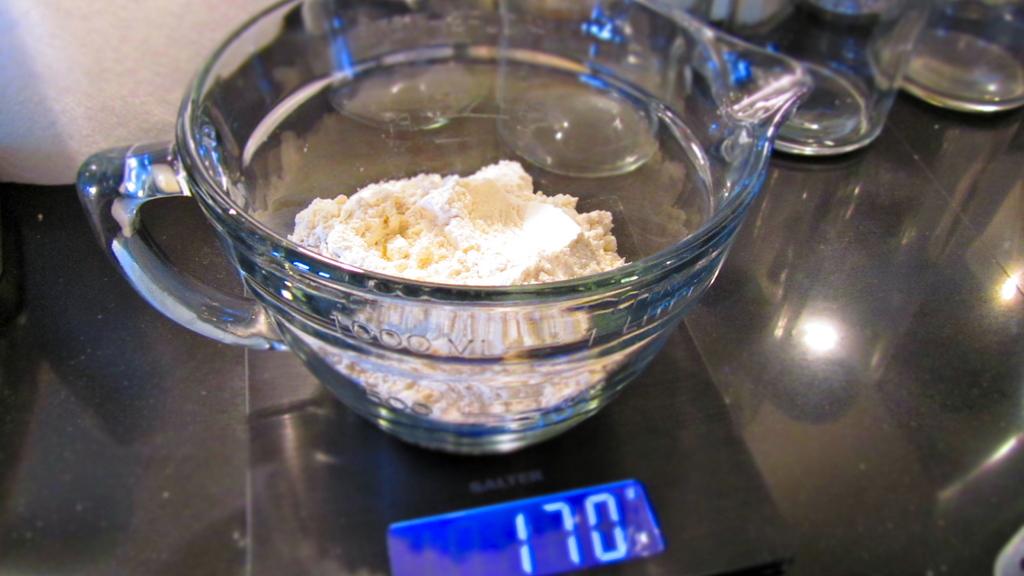What does this flour weigh?
Your answer should be very brief. 170. 